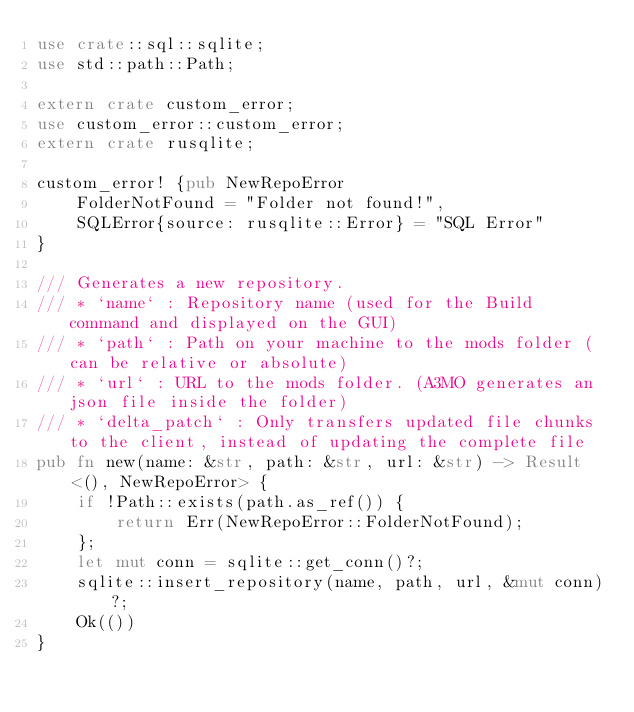Convert code to text. <code><loc_0><loc_0><loc_500><loc_500><_Rust_>use crate::sql::sqlite;
use std::path::Path;

extern crate custom_error;
use custom_error::custom_error;
extern crate rusqlite;

custom_error! {pub NewRepoError
    FolderNotFound = "Folder not found!",
    SQLError{source: rusqlite::Error} = "SQL Error"
}

/// Generates a new repository.
/// * `name` : Repository name (used for the Build command and displayed on the GUI)
/// * `path` : Path on your machine to the mods folder (can be relative or absolute)
/// * `url` : URL to the mods folder. (A3MO generates an json file inside the folder)
/// * `delta_patch` : Only transfers updated file chunks to the client, instead of updating the complete file
pub fn new(name: &str, path: &str, url: &str) -> Result<(), NewRepoError> {
    if !Path::exists(path.as_ref()) {
        return Err(NewRepoError::FolderNotFound);
    };
    let mut conn = sqlite::get_conn()?;
    sqlite::insert_repository(name, path, url, &mut conn)?;
    Ok(())
}
</code> 